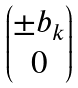Convert formula to latex. <formula><loc_0><loc_0><loc_500><loc_500>\begin{pmatrix} \pm b _ { k } \\ 0 \end{pmatrix}</formula> 